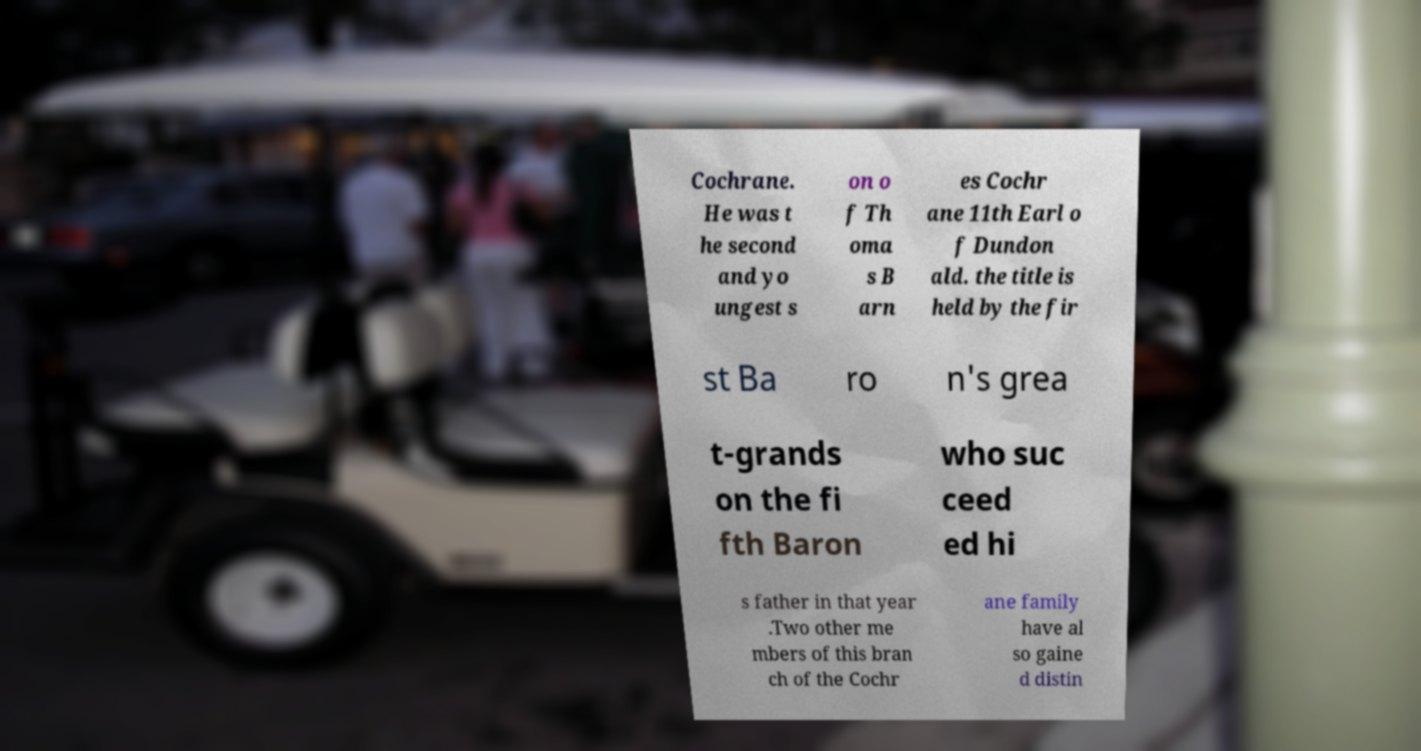Can you accurately transcribe the text from the provided image for me? Cochrane. He was t he second and yo ungest s on o f Th oma s B arn es Cochr ane 11th Earl o f Dundon ald. the title is held by the fir st Ba ro n's grea t-grands on the fi fth Baron who suc ceed ed hi s father in that year .Two other me mbers of this bran ch of the Cochr ane family have al so gaine d distin 